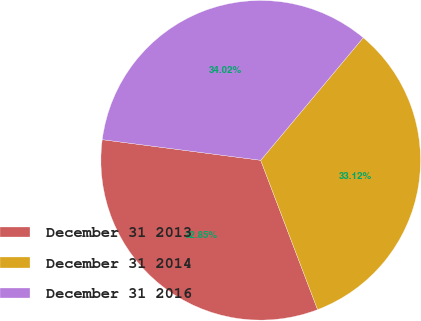<chart> <loc_0><loc_0><loc_500><loc_500><pie_chart><fcel>December 31 2013<fcel>December 31 2014<fcel>December 31 2016<nl><fcel>32.85%<fcel>33.12%<fcel>34.02%<nl></chart> 